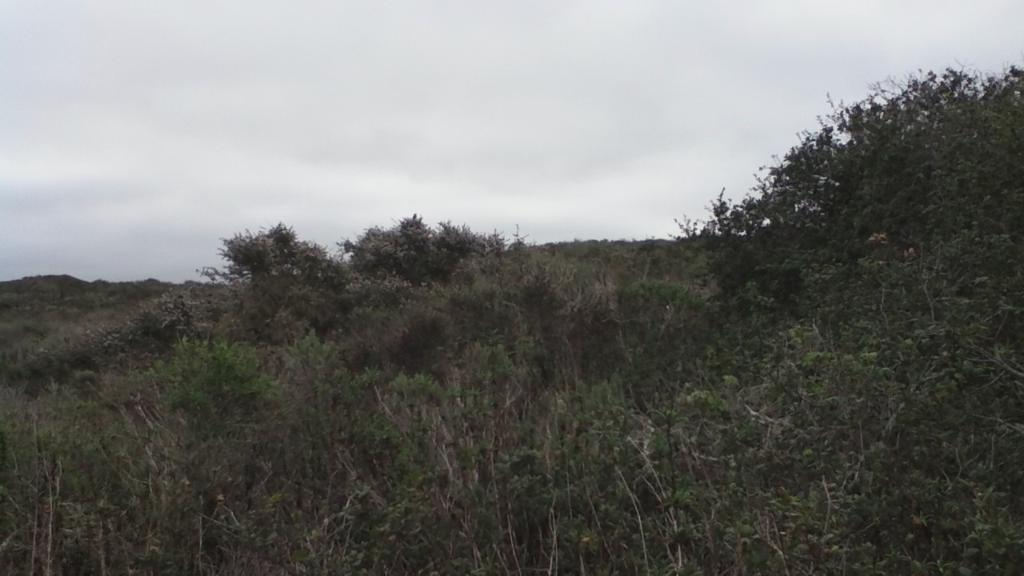What type of vegetation can be seen in the image? There are trees in the image. What part of the natural environment is visible in the image? The sky is visible in the background of the image. What religious symbols can be seen in the image? There are no religious symbols present in the image; it features trees and the sky. What historical event is depicted in the image? There is no historical event depicted in the image; it features trees and the sky. 